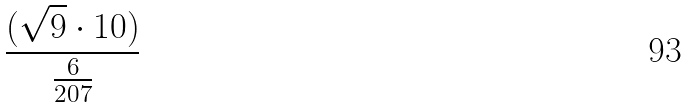<formula> <loc_0><loc_0><loc_500><loc_500>\frac { ( \sqrt { 9 } \cdot 1 0 ) } { \frac { 6 } { 2 0 7 } }</formula> 